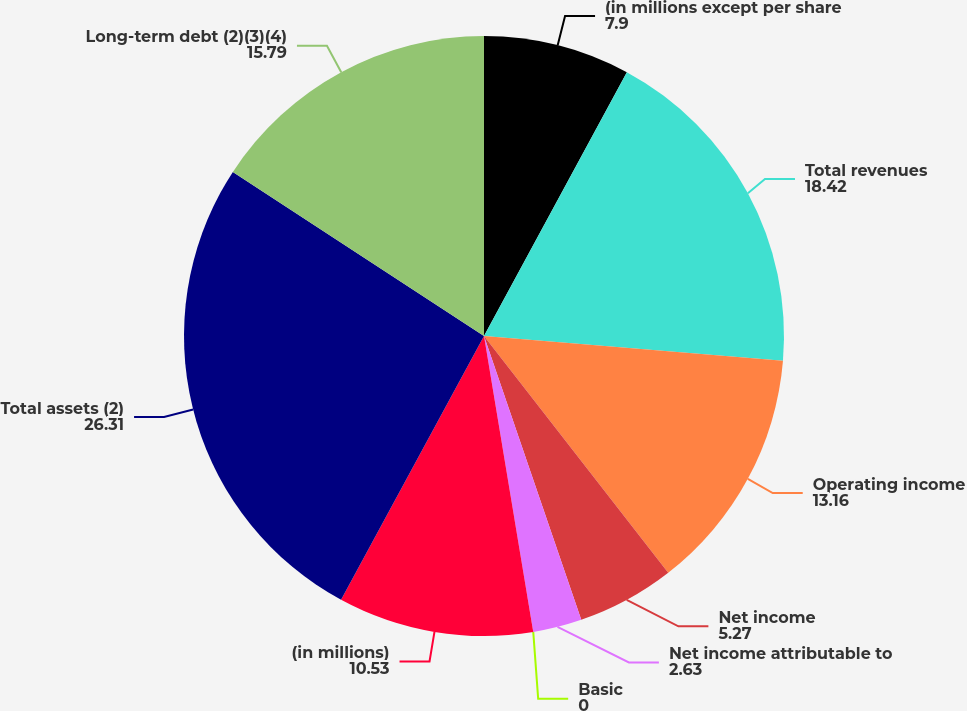<chart> <loc_0><loc_0><loc_500><loc_500><pie_chart><fcel>(in millions except per share<fcel>Total revenues<fcel>Operating income<fcel>Net income<fcel>Net income attributable to<fcel>Basic<fcel>(in millions)<fcel>Total assets (2)<fcel>Long-term debt (2)(3)(4)<nl><fcel>7.9%<fcel>18.42%<fcel>13.16%<fcel>5.27%<fcel>2.63%<fcel>0.0%<fcel>10.53%<fcel>26.31%<fcel>15.79%<nl></chart> 